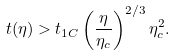<formula> <loc_0><loc_0><loc_500><loc_500>t ( \eta ) > t _ { 1 C } \left ( \frac { \eta } { \eta _ { c } } \right ) ^ { 2 / 3 } \eta _ { c } ^ { 2 } .</formula> 